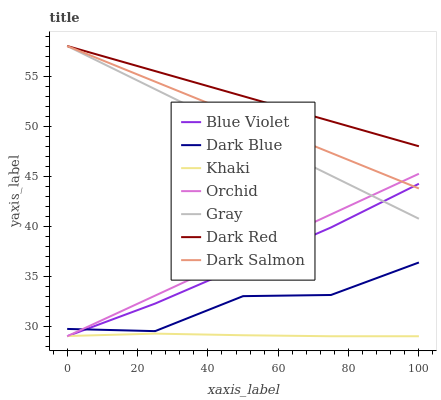Does Khaki have the minimum area under the curve?
Answer yes or no. Yes. Does Dark Red have the maximum area under the curve?
Answer yes or no. Yes. Does Dark Red have the minimum area under the curve?
Answer yes or no. No. Does Khaki have the maximum area under the curve?
Answer yes or no. No. Is Gray the smoothest?
Answer yes or no. Yes. Is Dark Blue the roughest?
Answer yes or no. Yes. Is Khaki the smoothest?
Answer yes or no. No. Is Khaki the roughest?
Answer yes or no. No. Does Khaki have the lowest value?
Answer yes or no. Yes. Does Dark Red have the lowest value?
Answer yes or no. No. Does Dark Salmon have the highest value?
Answer yes or no. Yes. Does Khaki have the highest value?
Answer yes or no. No. Is Khaki less than Dark Blue?
Answer yes or no. Yes. Is Dark Salmon greater than Khaki?
Answer yes or no. Yes. Does Dark Blue intersect Blue Violet?
Answer yes or no. Yes. Is Dark Blue less than Blue Violet?
Answer yes or no. No. Is Dark Blue greater than Blue Violet?
Answer yes or no. No. Does Khaki intersect Dark Blue?
Answer yes or no. No. 